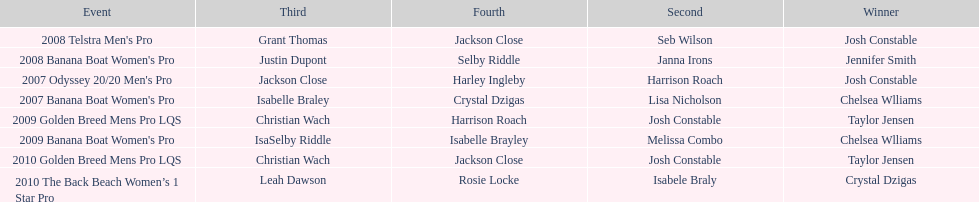Who was next to finish after josh constable in the 2008 telstra men's pro? Seb Wilson. 